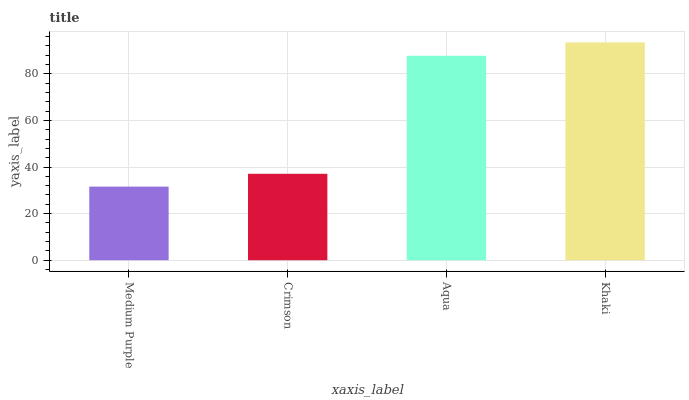Is Medium Purple the minimum?
Answer yes or no. Yes. Is Khaki the maximum?
Answer yes or no. Yes. Is Crimson the minimum?
Answer yes or no. No. Is Crimson the maximum?
Answer yes or no. No. Is Crimson greater than Medium Purple?
Answer yes or no. Yes. Is Medium Purple less than Crimson?
Answer yes or no. Yes. Is Medium Purple greater than Crimson?
Answer yes or no. No. Is Crimson less than Medium Purple?
Answer yes or no. No. Is Aqua the high median?
Answer yes or no. Yes. Is Crimson the low median?
Answer yes or no. Yes. Is Khaki the high median?
Answer yes or no. No. Is Khaki the low median?
Answer yes or no. No. 